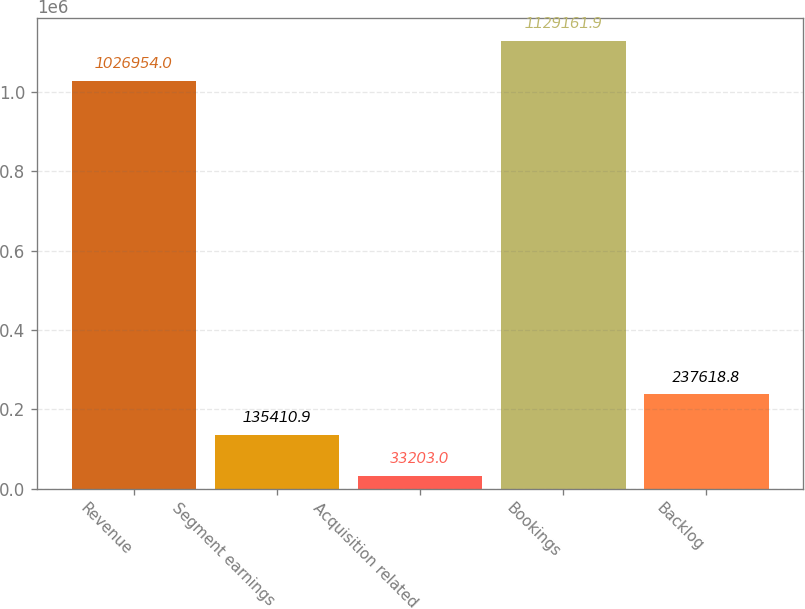<chart> <loc_0><loc_0><loc_500><loc_500><bar_chart><fcel>Revenue<fcel>Segment earnings<fcel>Acquisition related<fcel>Bookings<fcel>Backlog<nl><fcel>1.02695e+06<fcel>135411<fcel>33203<fcel>1.12916e+06<fcel>237619<nl></chart> 